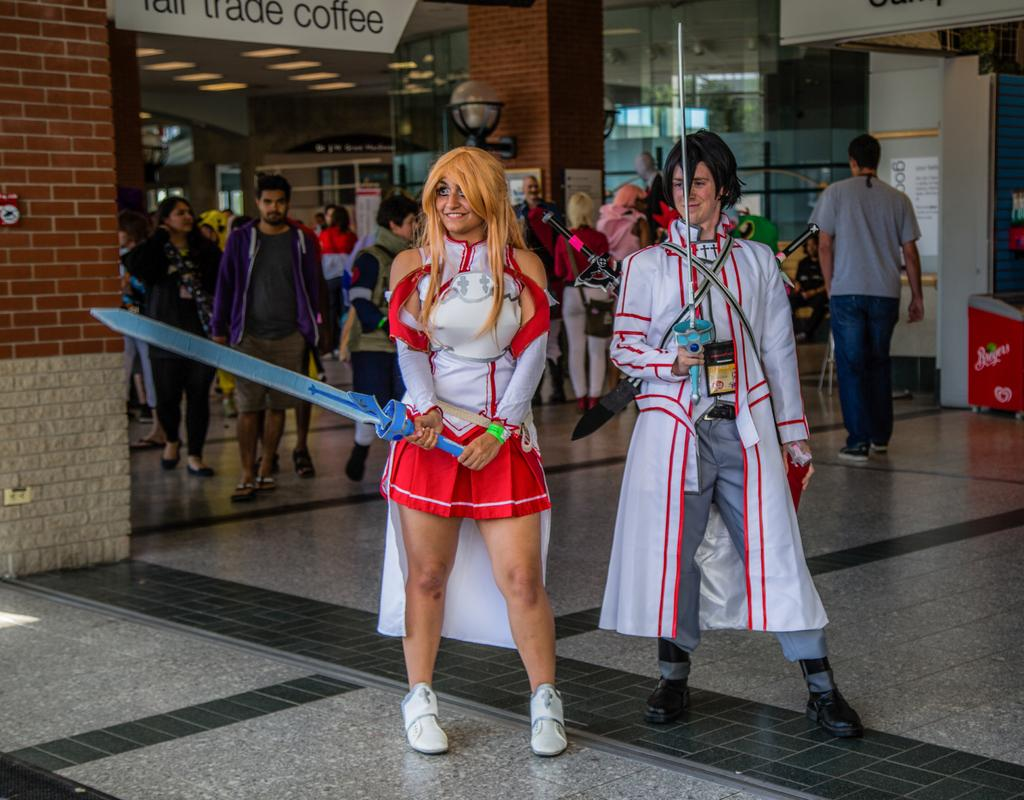Provide a one-sentence caption for the provided image. A woman swinging a toy sword in front of a Tall Trade Coffee store. 